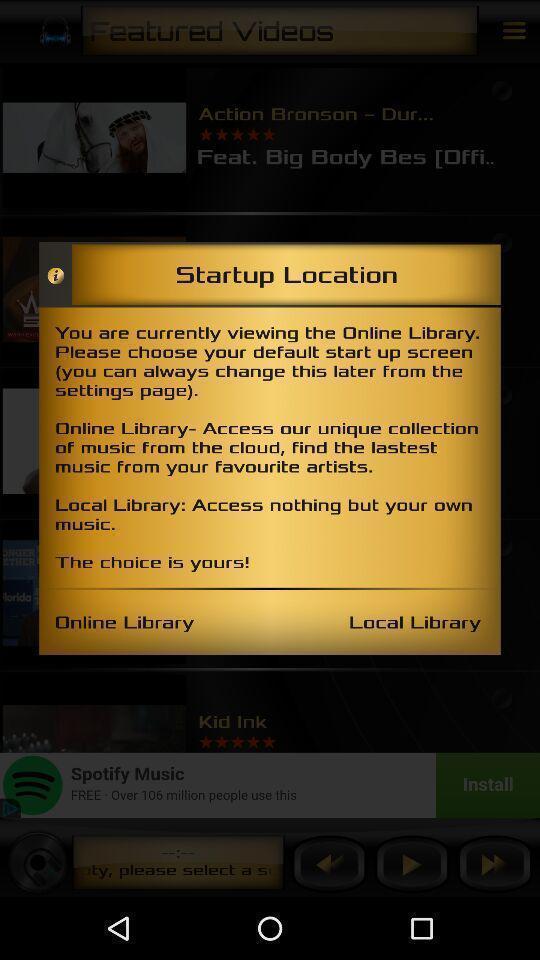Describe the content in this image. Pop-up shows multiple choices for music application. 